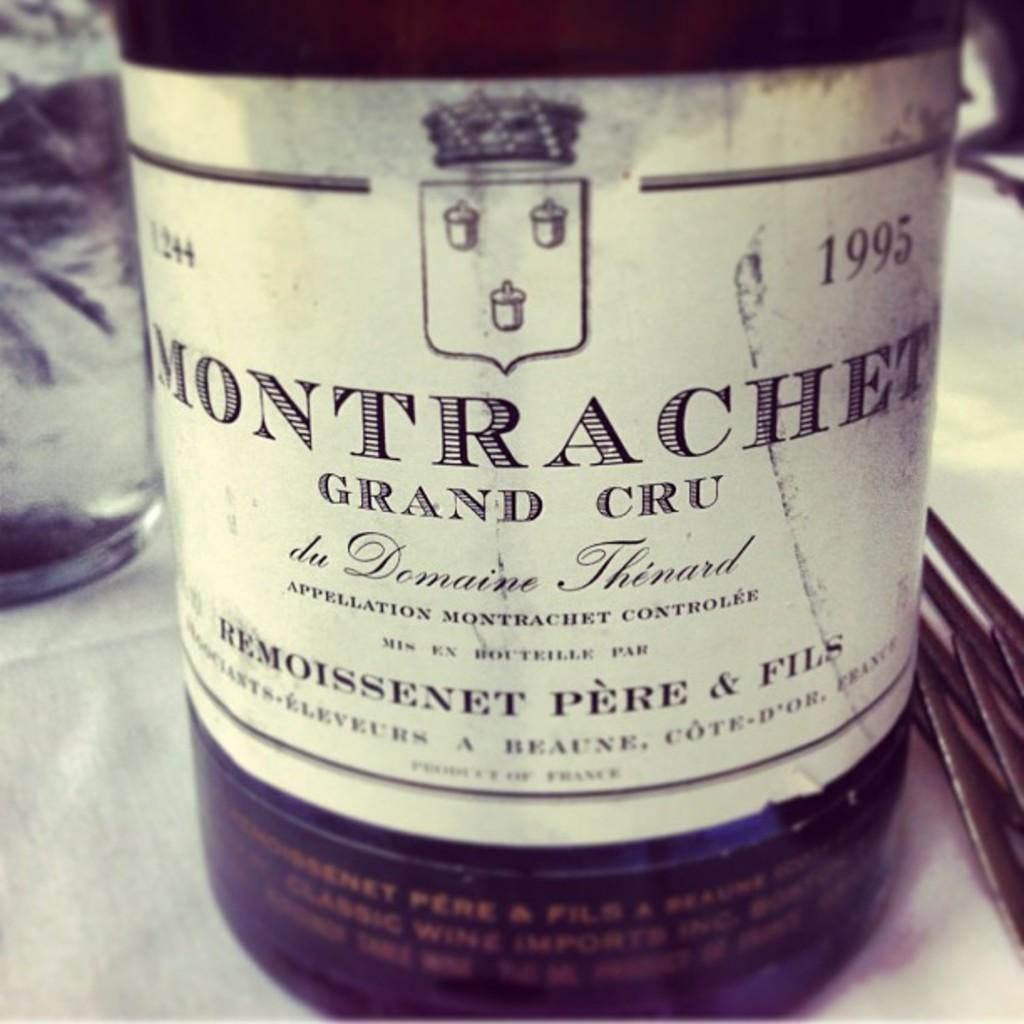<image>
Offer a succinct explanation of the picture presented. A bottle of Montrachet Grand Cru wine from 1995. 